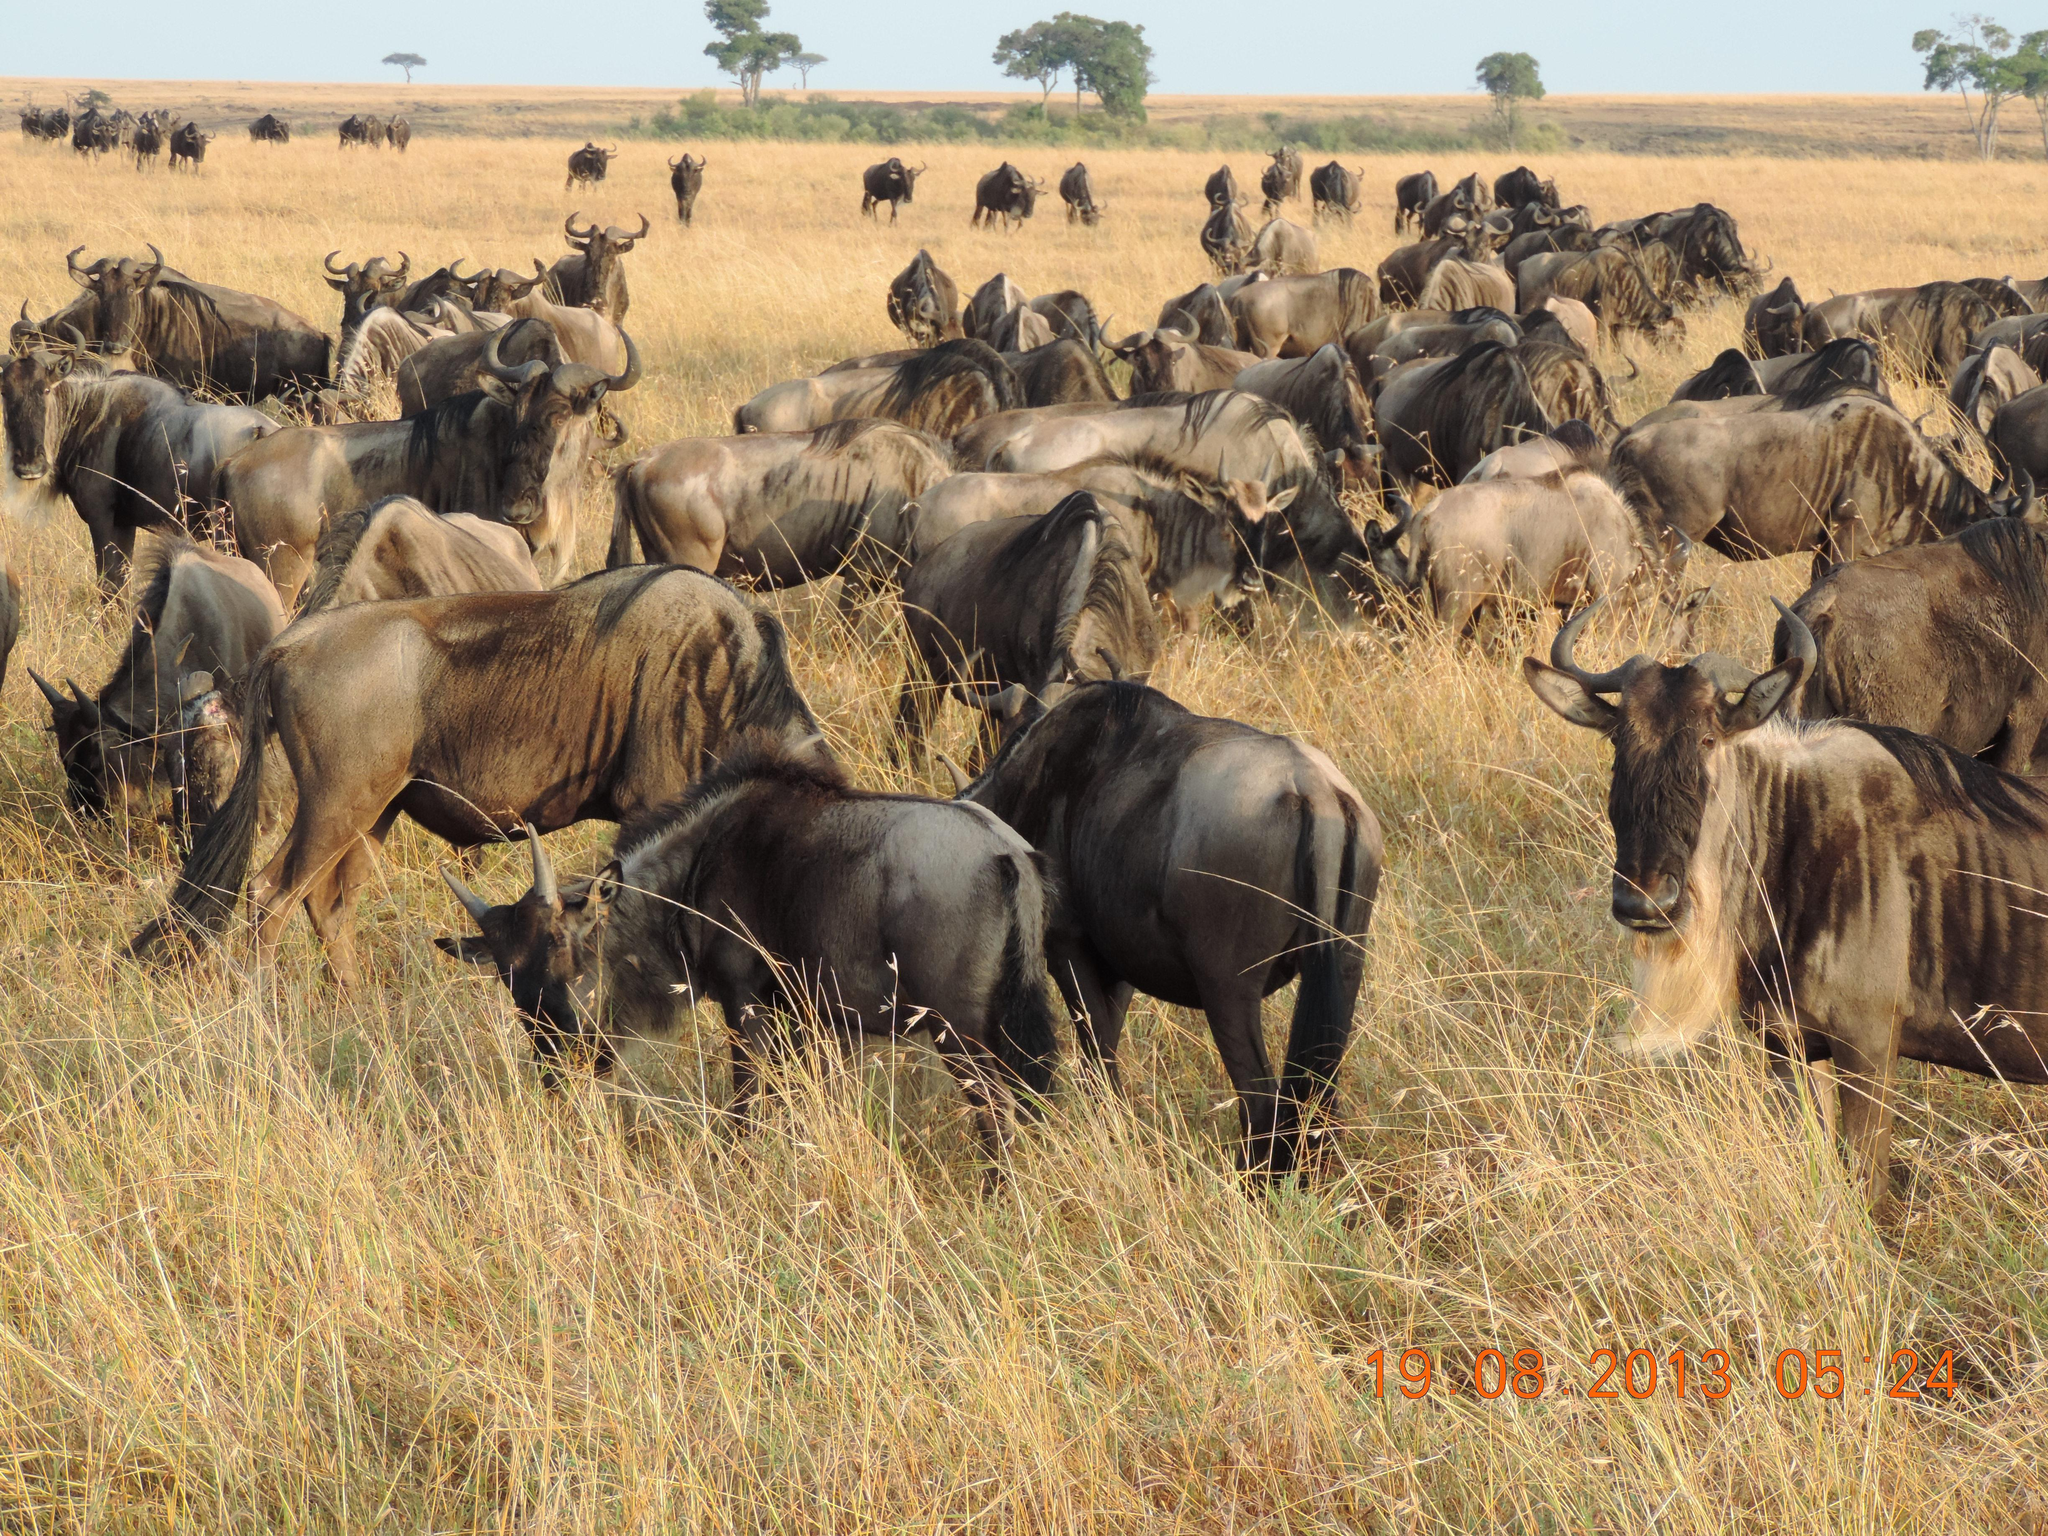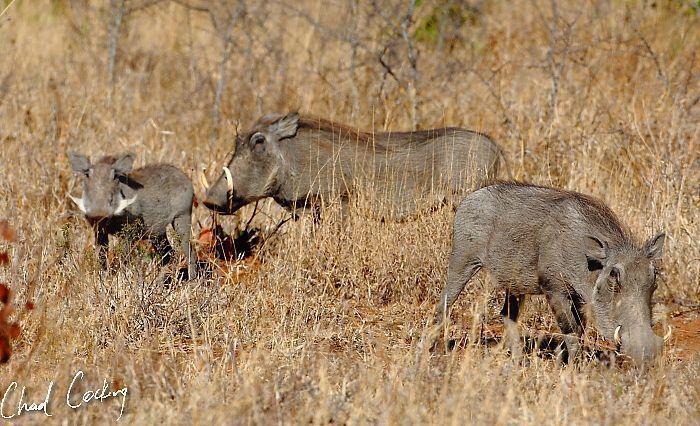The first image is the image on the left, the second image is the image on the right. Considering the images on both sides, is "One image contains no more than three animals." valid? Answer yes or no. Yes. 